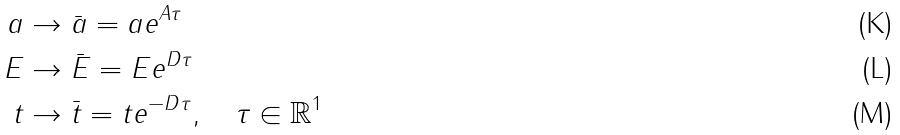<formula> <loc_0><loc_0><loc_500><loc_500>a & \to \bar { a } = a e ^ { A \tau } \\ E & \to \bar { E } = E e ^ { D \tau } \\ t & \to \bar { t } = t e ^ { - D \tau } , \quad \tau \in \mathbb { R } ^ { 1 }</formula> 